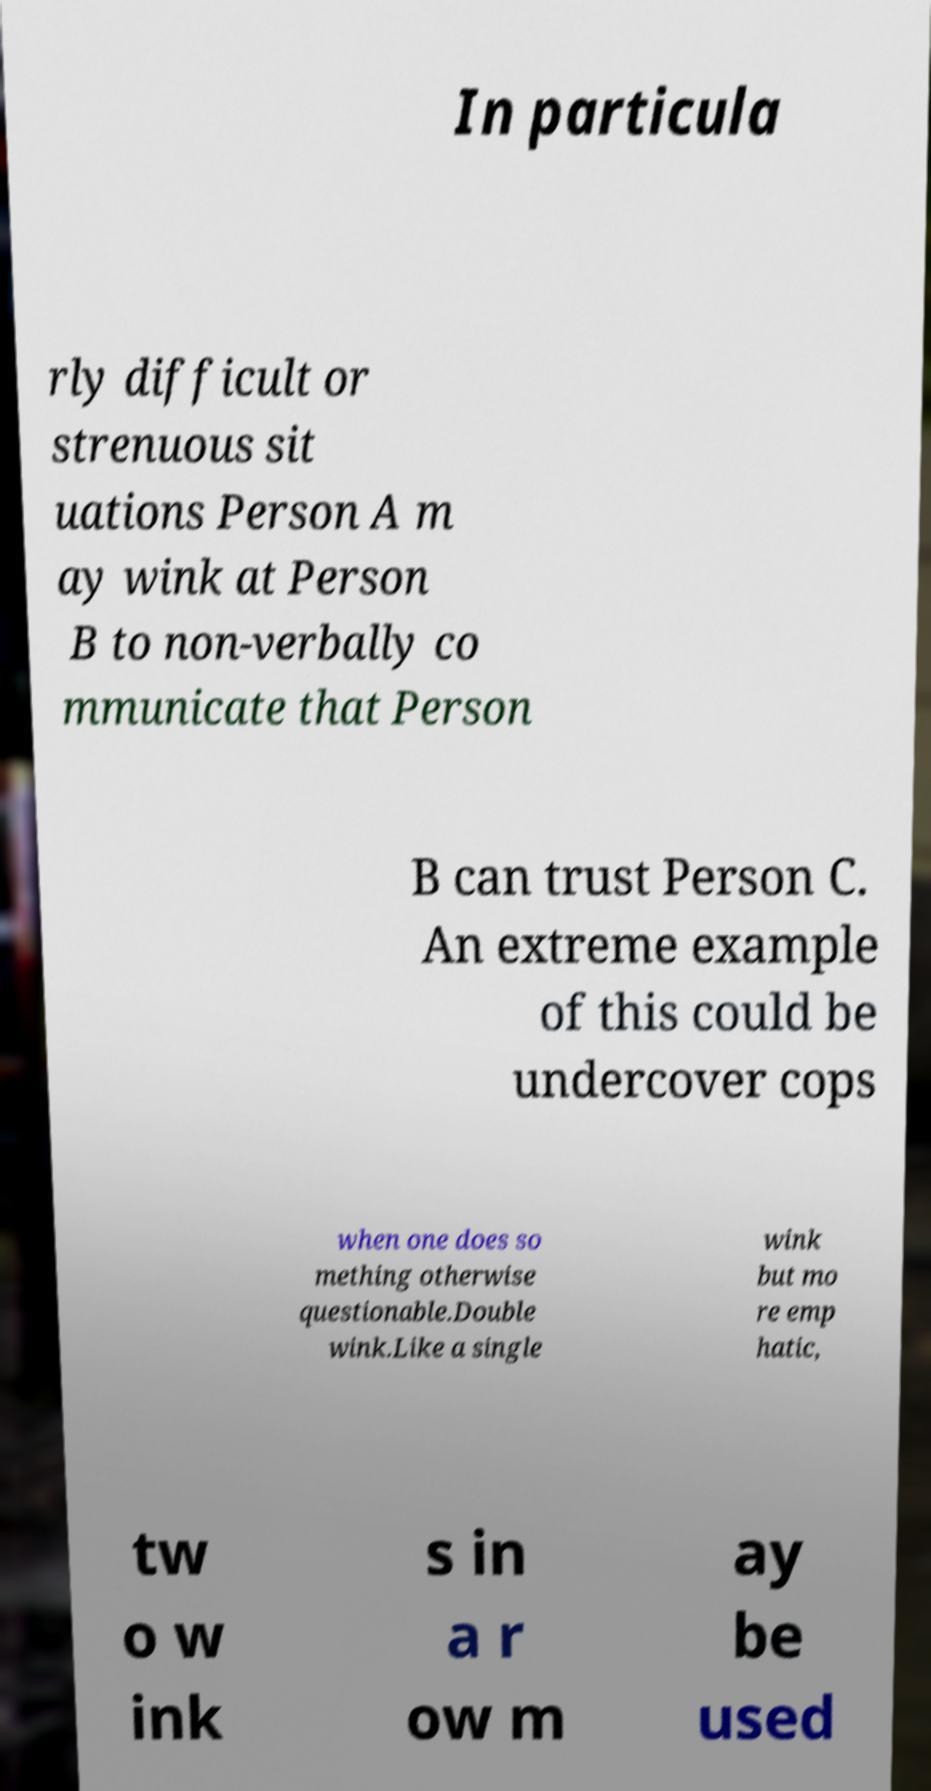Can you accurately transcribe the text from the provided image for me? In particula rly difficult or strenuous sit uations Person A m ay wink at Person B to non-verbally co mmunicate that Person B can trust Person C. An extreme example of this could be undercover cops when one does so mething otherwise questionable.Double wink.Like a single wink but mo re emp hatic, tw o w ink s in a r ow m ay be used 